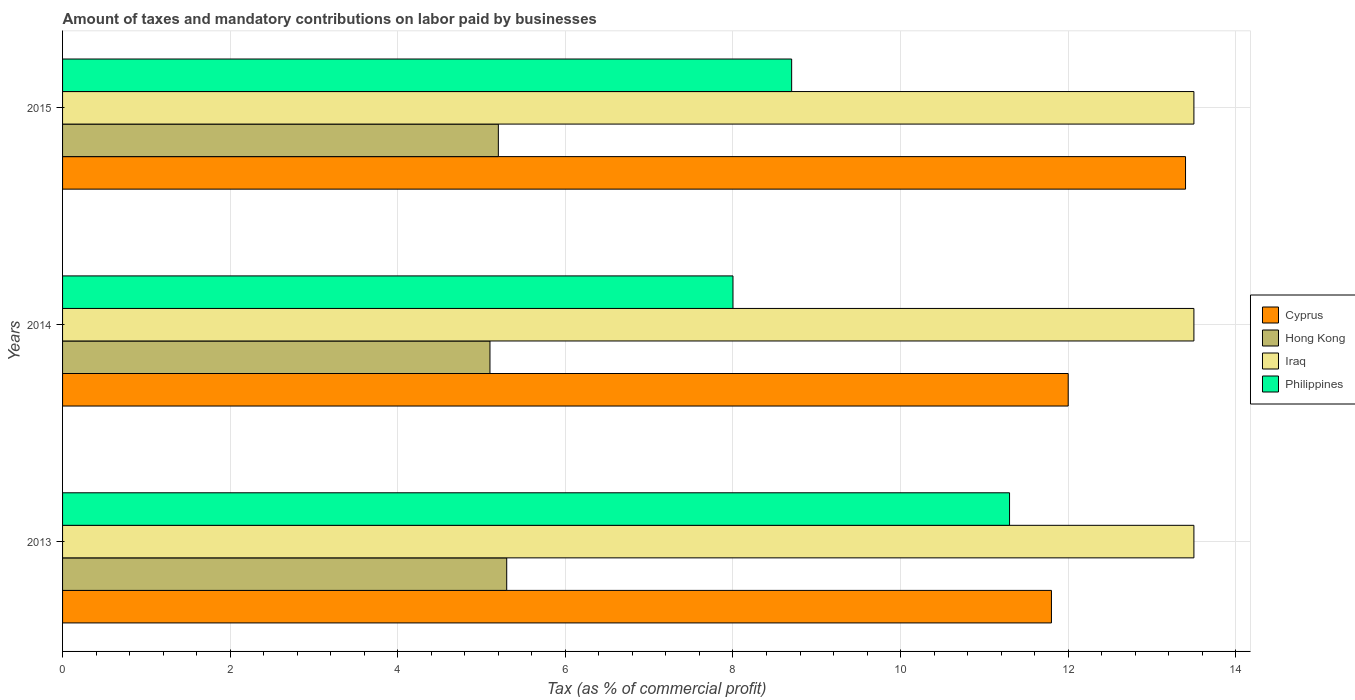How many different coloured bars are there?
Your answer should be compact. 4. How many groups of bars are there?
Provide a succinct answer. 3. Are the number of bars per tick equal to the number of legend labels?
Give a very brief answer. Yes. Are the number of bars on each tick of the Y-axis equal?
Your answer should be very brief. Yes. How many bars are there on the 2nd tick from the bottom?
Provide a short and direct response. 4. What is the label of the 2nd group of bars from the top?
Ensure brevity in your answer.  2014. In how many cases, is the number of bars for a given year not equal to the number of legend labels?
Provide a short and direct response. 0. What is the percentage of taxes paid by businesses in Cyprus in 2013?
Your answer should be very brief. 11.8. Across all years, what is the maximum percentage of taxes paid by businesses in Philippines?
Your answer should be compact. 11.3. Across all years, what is the minimum percentage of taxes paid by businesses in Philippines?
Ensure brevity in your answer.  8. In which year was the percentage of taxes paid by businesses in Philippines maximum?
Give a very brief answer. 2013. In which year was the percentage of taxes paid by businesses in Philippines minimum?
Offer a very short reply. 2014. What is the total percentage of taxes paid by businesses in Iraq in the graph?
Offer a very short reply. 40.5. What is the difference between the percentage of taxes paid by businesses in Iraq in 2013 and that in 2014?
Make the answer very short. 0. What is the difference between the percentage of taxes paid by businesses in Hong Kong in 2013 and the percentage of taxes paid by businesses in Cyprus in 2015?
Your answer should be compact. -8.1. What is the average percentage of taxes paid by businesses in Hong Kong per year?
Offer a terse response. 5.2. In the year 2013, what is the difference between the percentage of taxes paid by businesses in Iraq and percentage of taxes paid by businesses in Cyprus?
Offer a terse response. 1.7. What is the ratio of the percentage of taxes paid by businesses in Cyprus in 2014 to that in 2015?
Ensure brevity in your answer.  0.9. Is the difference between the percentage of taxes paid by businesses in Iraq in 2014 and 2015 greater than the difference between the percentage of taxes paid by businesses in Cyprus in 2014 and 2015?
Your response must be concise. Yes. What is the difference between the highest and the second highest percentage of taxes paid by businesses in Hong Kong?
Provide a short and direct response. 0.1. What is the difference between the highest and the lowest percentage of taxes paid by businesses in Philippines?
Keep it short and to the point. 3.3. In how many years, is the percentage of taxes paid by businesses in Iraq greater than the average percentage of taxes paid by businesses in Iraq taken over all years?
Make the answer very short. 0. What does the 4th bar from the top in 2014 represents?
Provide a succinct answer. Cyprus. What does the 4th bar from the bottom in 2015 represents?
Your response must be concise. Philippines. Is it the case that in every year, the sum of the percentage of taxes paid by businesses in Hong Kong and percentage of taxes paid by businesses in Iraq is greater than the percentage of taxes paid by businesses in Cyprus?
Your response must be concise. Yes. How many bars are there?
Your answer should be compact. 12. Are all the bars in the graph horizontal?
Make the answer very short. Yes. How many years are there in the graph?
Your response must be concise. 3. Does the graph contain any zero values?
Your answer should be very brief. No. Does the graph contain grids?
Your answer should be compact. Yes. What is the title of the graph?
Provide a succinct answer. Amount of taxes and mandatory contributions on labor paid by businesses. Does "Cambodia" appear as one of the legend labels in the graph?
Give a very brief answer. No. What is the label or title of the X-axis?
Keep it short and to the point. Tax (as % of commercial profit). What is the label or title of the Y-axis?
Your answer should be very brief. Years. What is the Tax (as % of commercial profit) in Cyprus in 2013?
Offer a very short reply. 11.8. What is the Tax (as % of commercial profit) in Cyprus in 2014?
Your answer should be compact. 12. What is the Tax (as % of commercial profit) of Iraq in 2014?
Your answer should be very brief. 13.5. What is the Tax (as % of commercial profit) in Philippines in 2014?
Offer a very short reply. 8. Across all years, what is the maximum Tax (as % of commercial profit) in Iraq?
Provide a succinct answer. 13.5. Across all years, what is the minimum Tax (as % of commercial profit) in Philippines?
Your response must be concise. 8. What is the total Tax (as % of commercial profit) in Cyprus in the graph?
Give a very brief answer. 37.2. What is the total Tax (as % of commercial profit) of Hong Kong in the graph?
Your answer should be very brief. 15.6. What is the total Tax (as % of commercial profit) in Iraq in the graph?
Ensure brevity in your answer.  40.5. What is the difference between the Tax (as % of commercial profit) of Cyprus in 2013 and that in 2014?
Offer a terse response. -0.2. What is the difference between the Tax (as % of commercial profit) in Hong Kong in 2013 and that in 2014?
Provide a succinct answer. 0.2. What is the difference between the Tax (as % of commercial profit) of Iraq in 2013 and that in 2015?
Provide a succinct answer. 0. What is the difference between the Tax (as % of commercial profit) of Philippines in 2013 and that in 2015?
Ensure brevity in your answer.  2.6. What is the difference between the Tax (as % of commercial profit) of Iraq in 2014 and that in 2015?
Provide a succinct answer. 0. What is the difference between the Tax (as % of commercial profit) in Philippines in 2014 and that in 2015?
Give a very brief answer. -0.7. What is the difference between the Tax (as % of commercial profit) of Cyprus in 2013 and the Tax (as % of commercial profit) of Philippines in 2014?
Keep it short and to the point. 3.8. What is the difference between the Tax (as % of commercial profit) of Iraq in 2013 and the Tax (as % of commercial profit) of Philippines in 2014?
Provide a succinct answer. 5.5. What is the difference between the Tax (as % of commercial profit) of Cyprus in 2013 and the Tax (as % of commercial profit) of Hong Kong in 2015?
Your answer should be compact. 6.6. What is the difference between the Tax (as % of commercial profit) in Cyprus in 2013 and the Tax (as % of commercial profit) in Philippines in 2015?
Provide a succinct answer. 3.1. What is the difference between the Tax (as % of commercial profit) in Cyprus in 2014 and the Tax (as % of commercial profit) in Philippines in 2015?
Provide a short and direct response. 3.3. What is the difference between the Tax (as % of commercial profit) of Hong Kong in 2014 and the Tax (as % of commercial profit) of Iraq in 2015?
Provide a short and direct response. -8.4. What is the difference between the Tax (as % of commercial profit) of Iraq in 2014 and the Tax (as % of commercial profit) of Philippines in 2015?
Your response must be concise. 4.8. What is the average Tax (as % of commercial profit) in Cyprus per year?
Give a very brief answer. 12.4. What is the average Tax (as % of commercial profit) in Hong Kong per year?
Your answer should be very brief. 5.2. What is the average Tax (as % of commercial profit) of Iraq per year?
Offer a very short reply. 13.5. What is the average Tax (as % of commercial profit) of Philippines per year?
Your answer should be compact. 9.33. In the year 2013, what is the difference between the Tax (as % of commercial profit) in Cyprus and Tax (as % of commercial profit) in Iraq?
Your answer should be compact. -1.7. In the year 2013, what is the difference between the Tax (as % of commercial profit) of Hong Kong and Tax (as % of commercial profit) of Iraq?
Your answer should be very brief. -8.2. In the year 2013, what is the difference between the Tax (as % of commercial profit) in Hong Kong and Tax (as % of commercial profit) in Philippines?
Give a very brief answer. -6. In the year 2013, what is the difference between the Tax (as % of commercial profit) in Iraq and Tax (as % of commercial profit) in Philippines?
Give a very brief answer. 2.2. In the year 2014, what is the difference between the Tax (as % of commercial profit) of Cyprus and Tax (as % of commercial profit) of Hong Kong?
Provide a short and direct response. 6.9. In the year 2014, what is the difference between the Tax (as % of commercial profit) of Cyprus and Tax (as % of commercial profit) of Iraq?
Your answer should be compact. -1.5. In the year 2014, what is the difference between the Tax (as % of commercial profit) in Cyprus and Tax (as % of commercial profit) in Philippines?
Keep it short and to the point. 4. In the year 2014, what is the difference between the Tax (as % of commercial profit) in Hong Kong and Tax (as % of commercial profit) in Iraq?
Make the answer very short. -8.4. In the year 2014, what is the difference between the Tax (as % of commercial profit) in Hong Kong and Tax (as % of commercial profit) in Philippines?
Provide a short and direct response. -2.9. In the year 2014, what is the difference between the Tax (as % of commercial profit) of Iraq and Tax (as % of commercial profit) of Philippines?
Offer a very short reply. 5.5. In the year 2015, what is the difference between the Tax (as % of commercial profit) of Cyprus and Tax (as % of commercial profit) of Iraq?
Your response must be concise. -0.1. In the year 2015, what is the difference between the Tax (as % of commercial profit) in Hong Kong and Tax (as % of commercial profit) in Iraq?
Offer a very short reply. -8.3. In the year 2015, what is the difference between the Tax (as % of commercial profit) of Iraq and Tax (as % of commercial profit) of Philippines?
Offer a terse response. 4.8. What is the ratio of the Tax (as % of commercial profit) of Cyprus in 2013 to that in 2014?
Your response must be concise. 0.98. What is the ratio of the Tax (as % of commercial profit) of Hong Kong in 2013 to that in 2014?
Your response must be concise. 1.04. What is the ratio of the Tax (as % of commercial profit) of Iraq in 2013 to that in 2014?
Your answer should be very brief. 1. What is the ratio of the Tax (as % of commercial profit) in Philippines in 2013 to that in 2014?
Offer a very short reply. 1.41. What is the ratio of the Tax (as % of commercial profit) in Cyprus in 2013 to that in 2015?
Keep it short and to the point. 0.88. What is the ratio of the Tax (as % of commercial profit) in Hong Kong in 2013 to that in 2015?
Your response must be concise. 1.02. What is the ratio of the Tax (as % of commercial profit) of Iraq in 2013 to that in 2015?
Your response must be concise. 1. What is the ratio of the Tax (as % of commercial profit) of Philippines in 2013 to that in 2015?
Ensure brevity in your answer.  1.3. What is the ratio of the Tax (as % of commercial profit) of Cyprus in 2014 to that in 2015?
Offer a terse response. 0.9. What is the ratio of the Tax (as % of commercial profit) in Hong Kong in 2014 to that in 2015?
Provide a short and direct response. 0.98. What is the ratio of the Tax (as % of commercial profit) of Philippines in 2014 to that in 2015?
Offer a very short reply. 0.92. What is the difference between the highest and the lowest Tax (as % of commercial profit) in Cyprus?
Your answer should be very brief. 1.6. What is the difference between the highest and the lowest Tax (as % of commercial profit) of Hong Kong?
Provide a short and direct response. 0.2. What is the difference between the highest and the lowest Tax (as % of commercial profit) of Iraq?
Your answer should be compact. 0. 